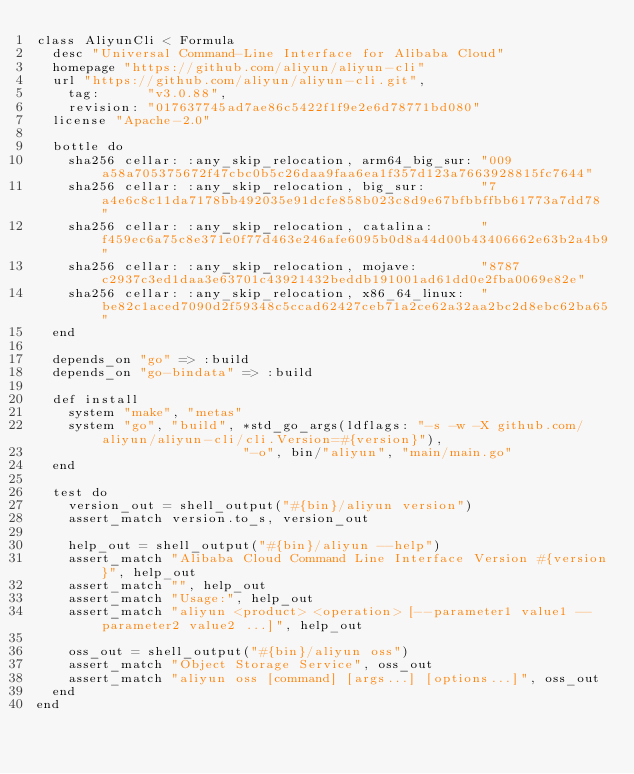Convert code to text. <code><loc_0><loc_0><loc_500><loc_500><_Ruby_>class AliyunCli < Formula
  desc "Universal Command-Line Interface for Alibaba Cloud"
  homepage "https://github.com/aliyun/aliyun-cli"
  url "https://github.com/aliyun/aliyun-cli.git",
    tag:      "v3.0.88",
    revision: "017637745ad7ae86c5422f1f9e2e6d78771bd080"
  license "Apache-2.0"

  bottle do
    sha256 cellar: :any_skip_relocation, arm64_big_sur: "009a58a705375672f47cbc0b5c26daa9faa6ea1f357d123a7663928815fc7644"
    sha256 cellar: :any_skip_relocation, big_sur:       "7a4e6c8c11da7178bb492035e91dcfe858b023c8d9e67bfbbffbb61773a7dd78"
    sha256 cellar: :any_skip_relocation, catalina:      "f459ec6a75c8e371e0f77d463e246afe6095b0d8a44d00b43406662e63b2a4b9"
    sha256 cellar: :any_skip_relocation, mojave:        "8787c2937c3ed1daa3e63701c43921432beddb191001ad61dd0e2fba0069e82e"
    sha256 cellar: :any_skip_relocation, x86_64_linux:  "be82c1aced7090d2f59348c5ccad62427ceb71a2ce62a32aa2bc2d8ebc62ba65"
  end

  depends_on "go" => :build
  depends_on "go-bindata" => :build

  def install
    system "make", "metas"
    system "go", "build", *std_go_args(ldflags: "-s -w -X github.com/aliyun/aliyun-cli/cli.Version=#{version}"),
                          "-o", bin/"aliyun", "main/main.go"
  end

  test do
    version_out = shell_output("#{bin}/aliyun version")
    assert_match version.to_s, version_out

    help_out = shell_output("#{bin}/aliyun --help")
    assert_match "Alibaba Cloud Command Line Interface Version #{version}", help_out
    assert_match "", help_out
    assert_match "Usage:", help_out
    assert_match "aliyun <product> <operation> [--parameter1 value1 --parameter2 value2 ...]", help_out

    oss_out = shell_output("#{bin}/aliyun oss")
    assert_match "Object Storage Service", oss_out
    assert_match "aliyun oss [command] [args...] [options...]", oss_out
  end
end
</code> 